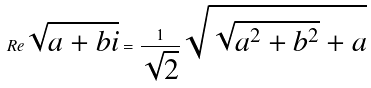Convert formula to latex. <formula><loc_0><loc_0><loc_500><loc_500>R e \sqrt { a + b i } = \frac { 1 } { \sqrt { 2 } } \sqrt { \sqrt { a ^ { 2 } + b ^ { 2 } } + a }</formula> 